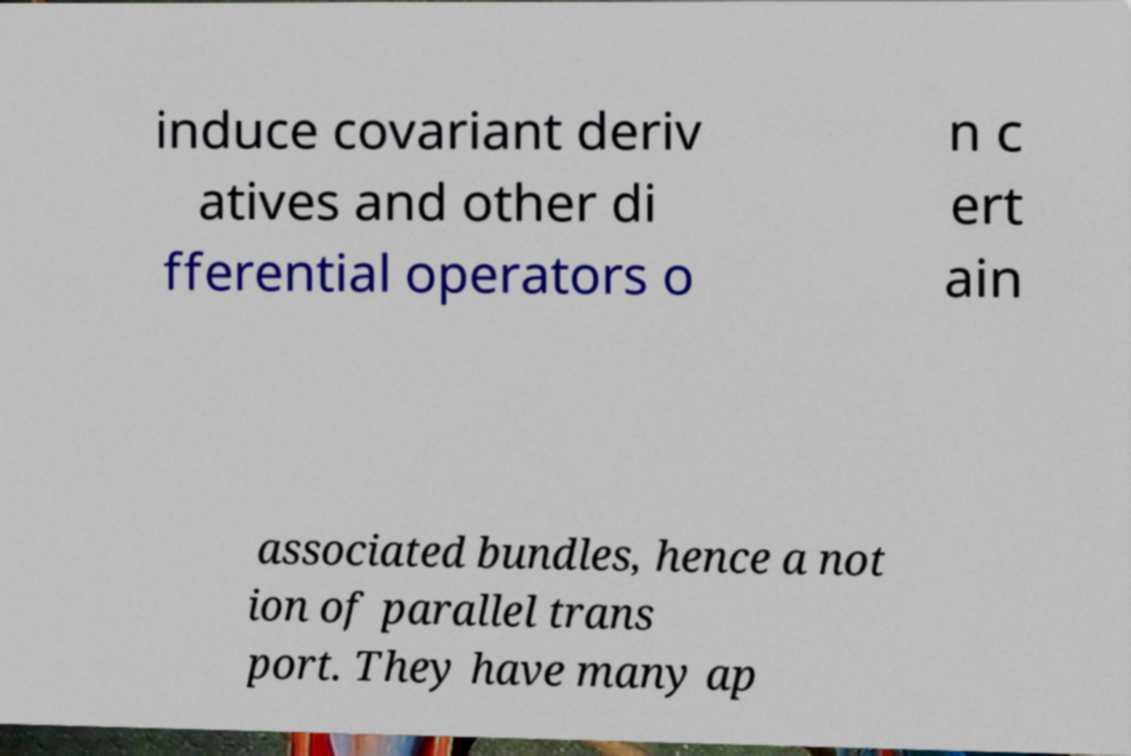Please read and relay the text visible in this image. What does it say? induce covariant deriv atives and other di fferential operators o n c ert ain associated bundles, hence a not ion of parallel trans port. They have many ap 